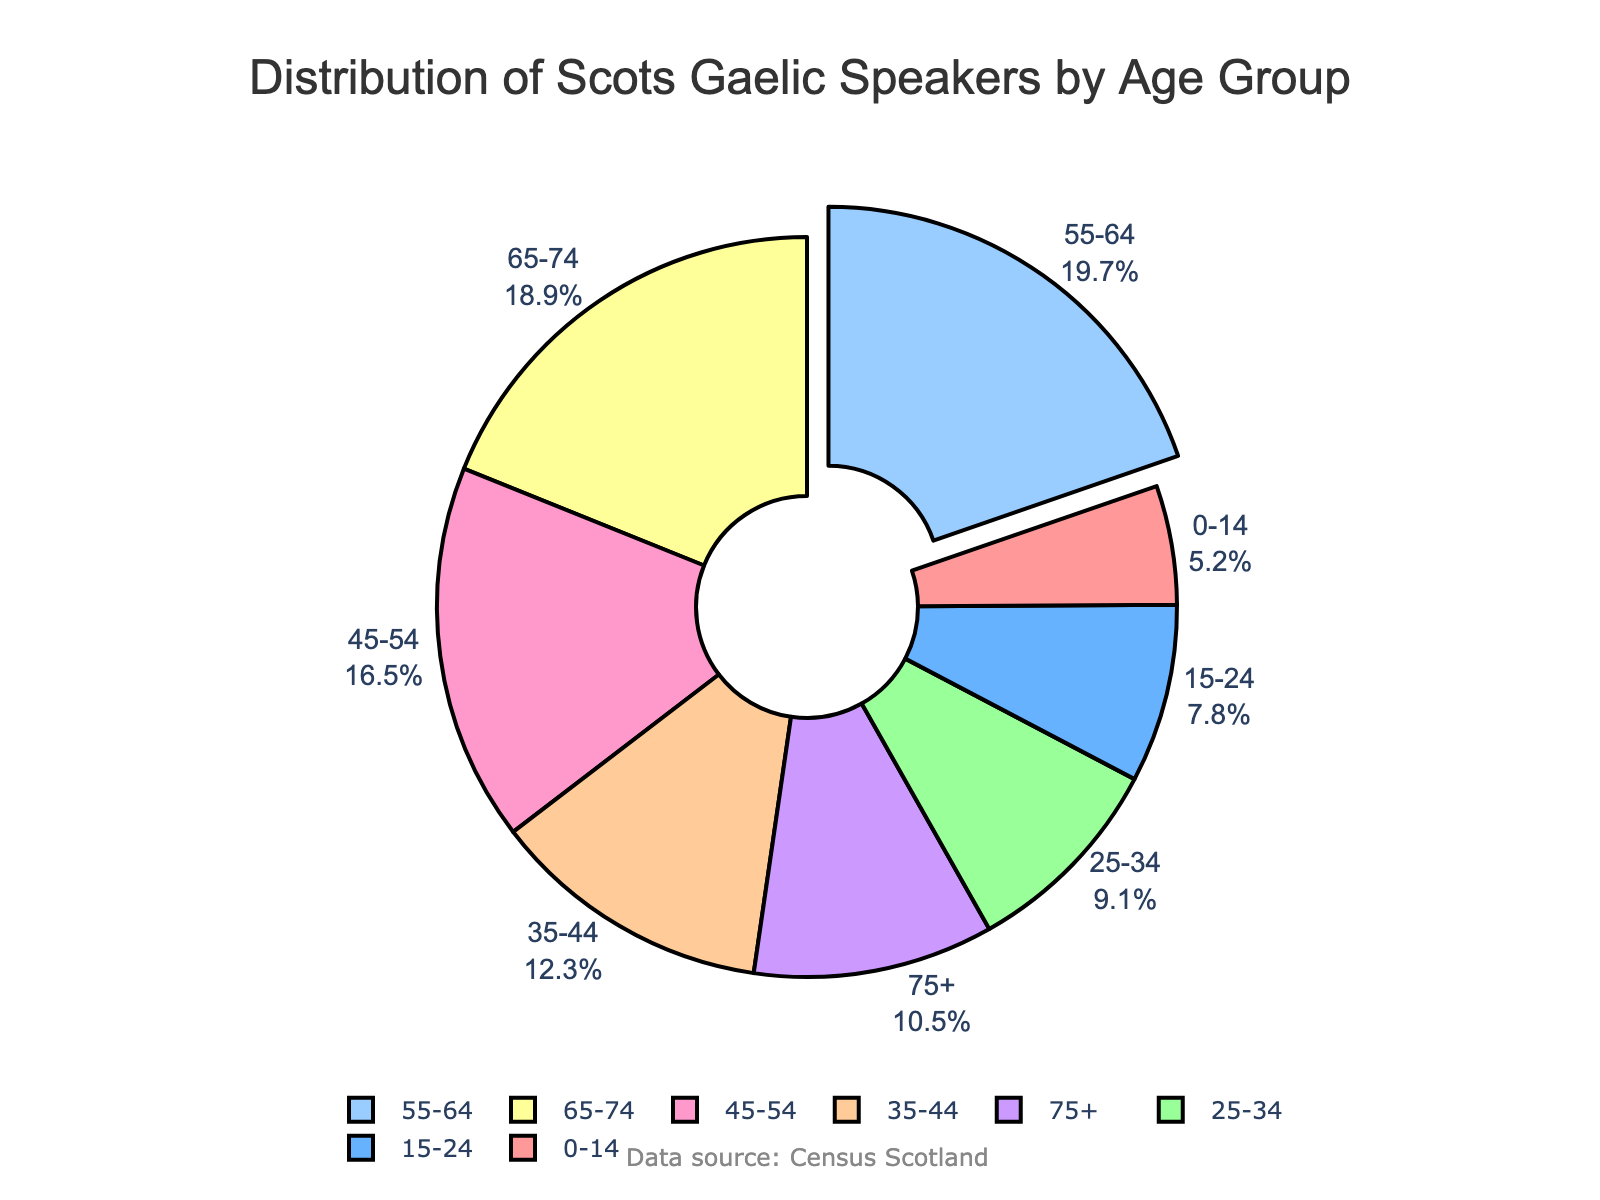Which age group has the highest percentage of Scots Gaelic speakers? The slice with the highest percentage is pulled out for emphasis. The label on this slice reads "55-64" with a percentage of 19.7%.
Answer: 55-64 Which age group has the lowest percentage of Scots Gaelic speakers? The smallest slice has the label "0-14" with a percentage of 5.2%.
Answer: 0-14 What is the combined percentage of the 45-54 and 55-64 age groups? Add the percentages of the 45-54 group (16.5%) and the 55-64 group (19.7%). 16.5% + 19.7% = 36.2%
Answer: 36.2% What is the difference in percentage between the age groups 35-44 and 65-74? Subtract the percentage of the 65-74 group (18.9%) from the 35-44 group (12.3%). 18.9% - 12.3% = 6.6%
Answer: 6.6% Which color represents the 25-34 age group in the pie chart? The color associated with the 25-34 age group in the legend is the third color listed, which is light green (#99FF99).
Answer: Light green Compare the percentage of speakers in the 75+ group with the 0-14 group. Which is higher and by how much? The percentage of speakers in the 75+ group is 10.5%, and in the 0-14 group is 5.2%. 10.5% - 5.2% = 5.3%, so the 75+ group is higher by 5.3%.
Answer: 75+ group by 5.3% What is the percentage of Scots Gaelic speakers aged 25-44? Combine the percentages of the 25-34 group (9.1%) and the 35-44 group (12.3%). 9.1% + 12.3% = 21.4%
Answer: 21.4% Identify the age group with the second-lowest percentage of Scots Gaelic speakers. The smallest percentage is for the 0-14 age group (5.2%), and the second smallest is the 15-24 group with 7.8%.
Answer: 15-24 Among the age groups 45-54, 55-64, and 65-74, which group has the highest percentage? Compare the percentages: 45-54 (16.5%), 55-64 (19.7%), 65-74 (18.9%). The highest percentage is for the 55-64 group with 19.7%.
Answer: 55-64 What can we infer about the age distribution of Scots Gaelic speakers from the pie chart? Most of the speakers are in older age groups. The combined percentage for the 45-54, 55-64, 65-74, and 75+ groups exceeds 65%, suggesting higher fluency in older generations.
Answer: Predominantly older ages 